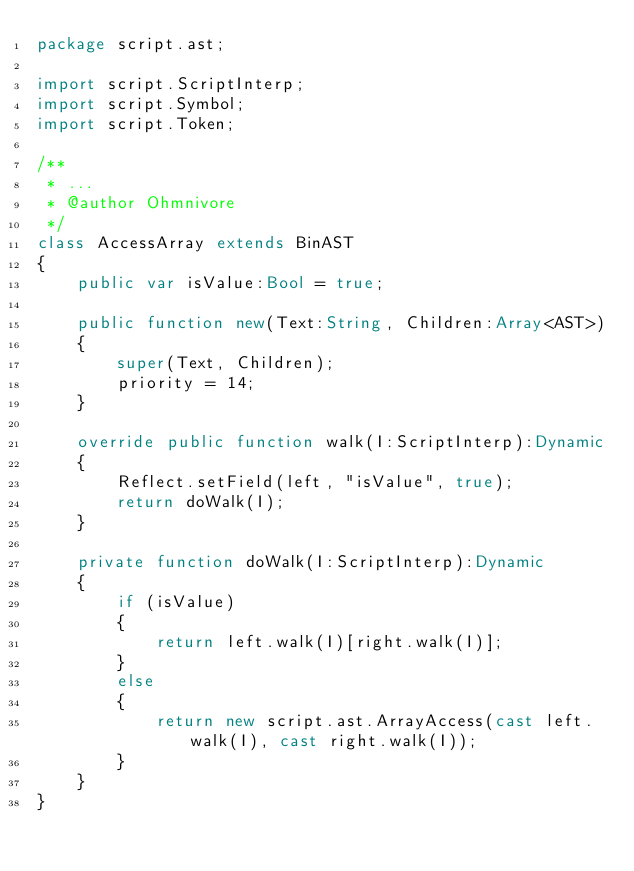Convert code to text. <code><loc_0><loc_0><loc_500><loc_500><_Haxe_>package script.ast;

import script.ScriptInterp;
import script.Symbol;
import script.Token;

/**
 * ...
 * @author Ohmnivore
 */
class AccessArray extends BinAST
{
	public var isValue:Bool = true;
	
	public function new(Text:String, Children:Array<AST>) 
	{
		super(Text, Children);
		priority = 14;
	}
	
	override public function walk(I:ScriptInterp):Dynamic 
	{
		Reflect.setField(left, "isValue", true);
		return doWalk(I);
	}
	
	private function doWalk(I:ScriptInterp):Dynamic
	{
		if (isValue)
		{
			return left.walk(I)[right.walk(I)];
		}
		else
		{
			return new script.ast.ArrayAccess(cast left.walk(I), cast right.walk(I));
		}
	}
}</code> 